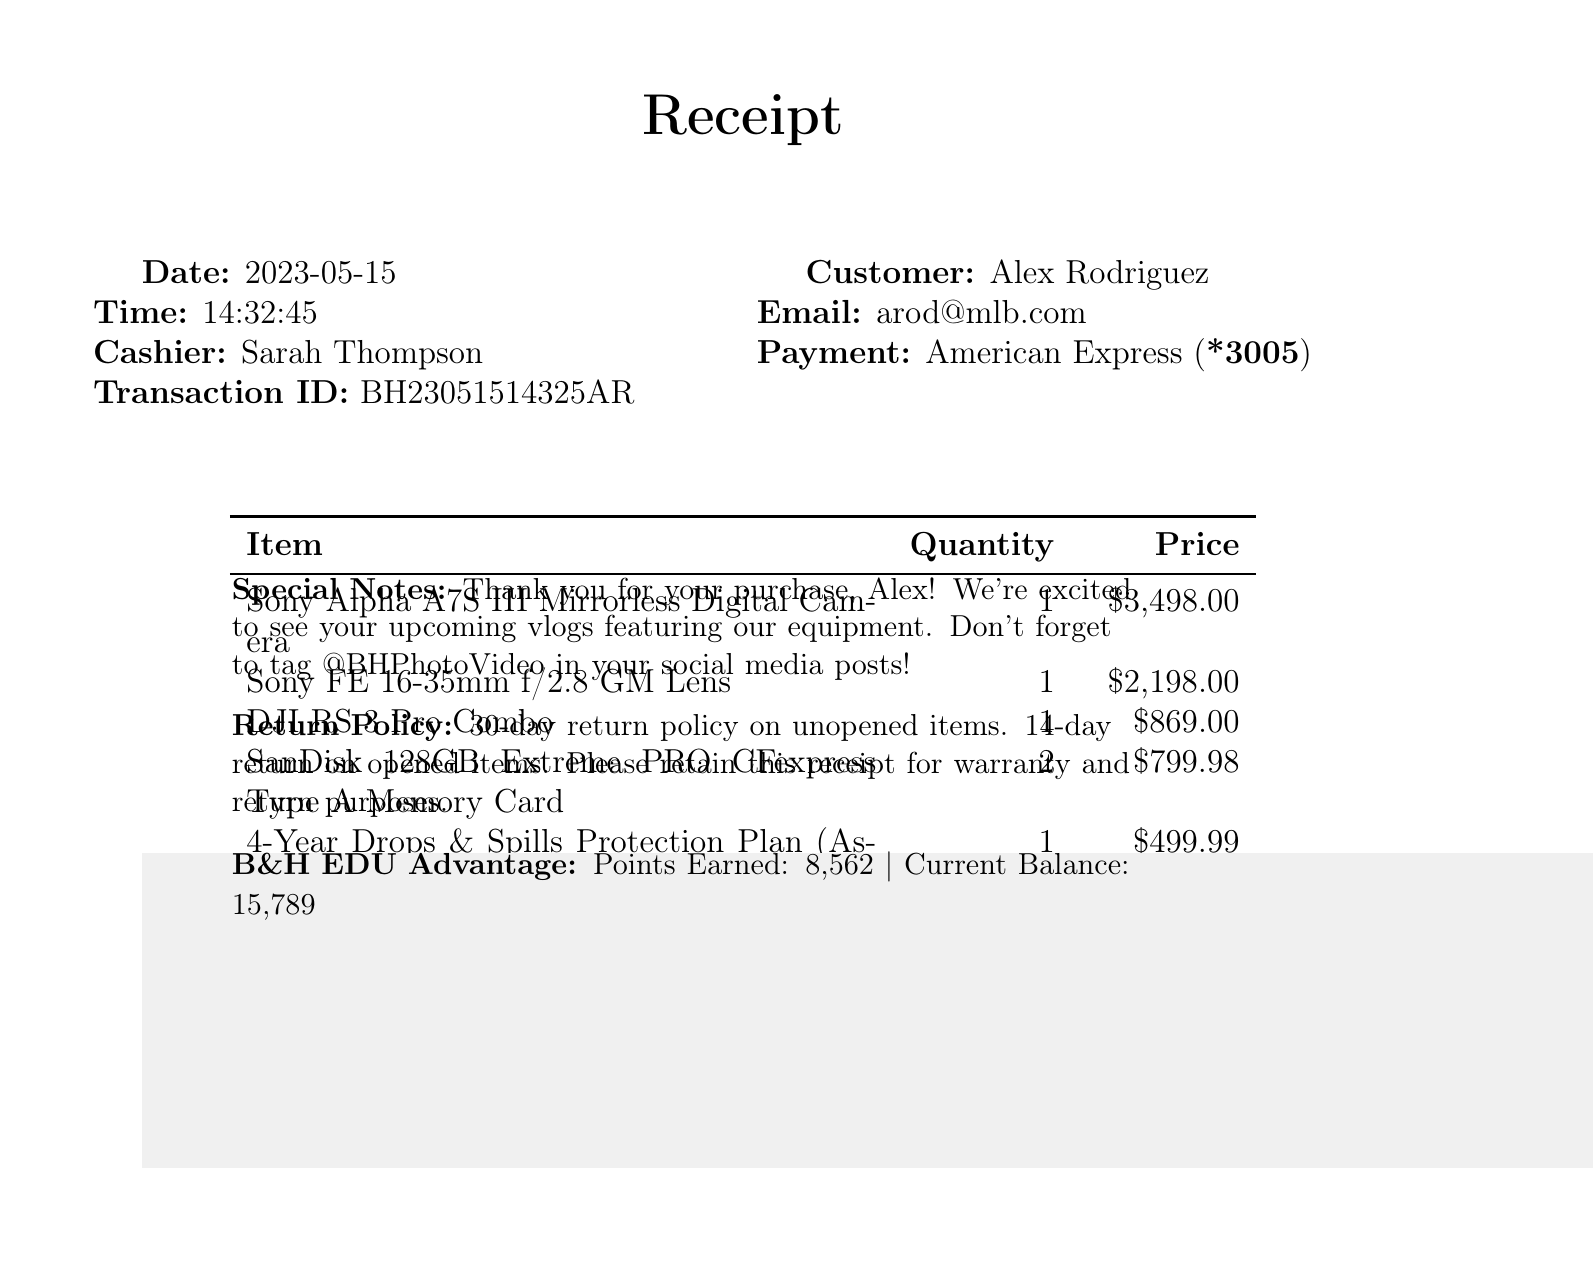what is the store name? The store name is indicated at the top of the receipt.
Answer: B&H Photo Video who was the cashier? The cashier's name is provided in the document under transaction details.
Answer: Sarah Thompson what is the date of purchase? The purchase date is listed prominently in the receipt.
Answer: 2023-05-15 how much is the total amount? The total amount is calculated at the bottom of the receipt.
Answer: $8,562.49 what warranty was purchased? The warranty name can be found among the items listed.
Answer: 4-Year Drops & Spills Protection Plan how many memory cards were bought? The quantity of the SanDisk memory cards is detailed in the itemized list.
Answer: 2 what was the subtotal amount before tax? The subtotal amount appears above the tax amount in the total calculation section.
Answer: $7,864.97 how many loyalty points were earned? The earned points are clearly stated under the loyalty program section.
Answer: 8,562 what is the return policy for opened items? The return policy for opened items is outlined in the special notes section.
Answer: 14-day return on opened items what is the store's Instagram handle? The social media details include the store's Instagram handle.
Answer: @BHPhotoVideo 